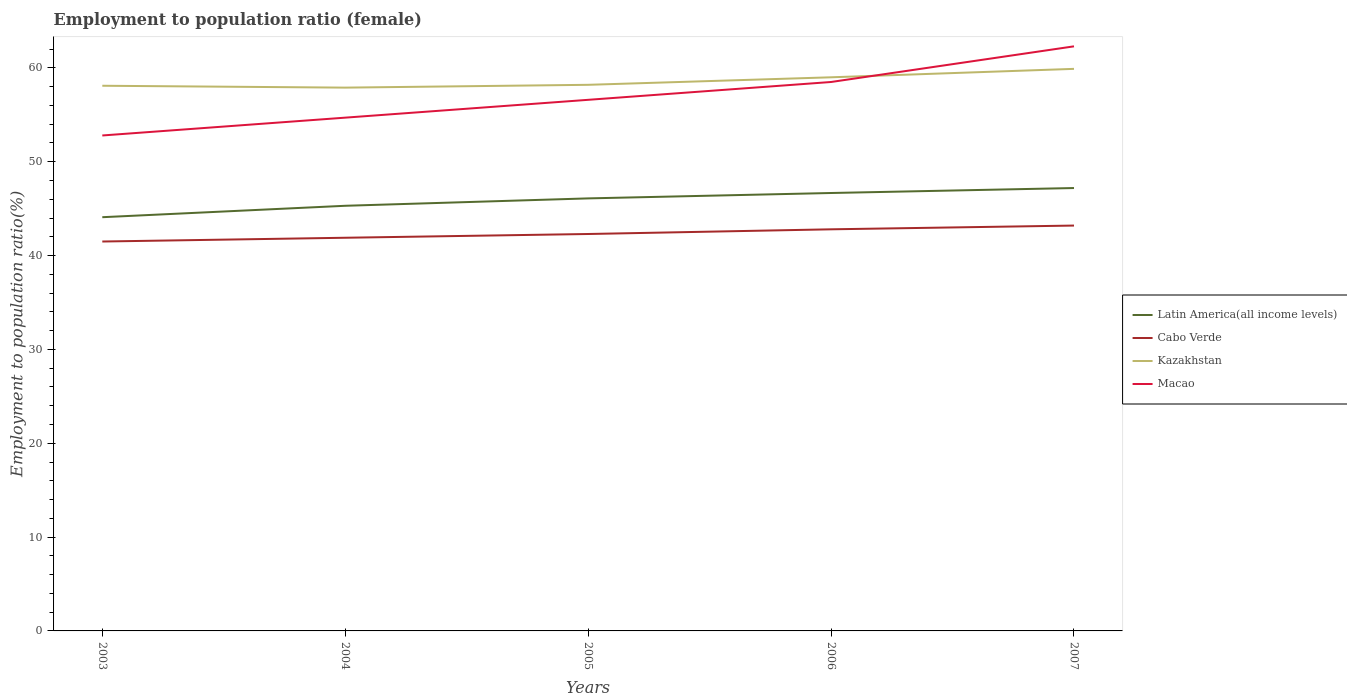How many different coloured lines are there?
Offer a very short reply. 4. Does the line corresponding to Kazakhstan intersect with the line corresponding to Cabo Verde?
Give a very brief answer. No. Across all years, what is the maximum employment to population ratio in Macao?
Give a very brief answer. 52.8. In which year was the employment to population ratio in Cabo Verde maximum?
Your answer should be compact. 2003. What is the total employment to population ratio in Cabo Verde in the graph?
Your response must be concise. -0.9. What is the difference between the highest and the second highest employment to population ratio in Latin America(all income levels)?
Your response must be concise. 3.11. What is the difference between the highest and the lowest employment to population ratio in Latin America(all income levels)?
Offer a terse response. 3. How many lines are there?
Ensure brevity in your answer.  4. Does the graph contain grids?
Your answer should be compact. No. What is the title of the graph?
Your response must be concise. Employment to population ratio (female). What is the label or title of the Y-axis?
Your answer should be very brief. Employment to population ratio(%). What is the Employment to population ratio(%) in Latin America(all income levels) in 2003?
Ensure brevity in your answer.  44.09. What is the Employment to population ratio(%) of Cabo Verde in 2003?
Give a very brief answer. 41.5. What is the Employment to population ratio(%) of Kazakhstan in 2003?
Keep it short and to the point. 58.1. What is the Employment to population ratio(%) in Macao in 2003?
Provide a succinct answer. 52.8. What is the Employment to population ratio(%) of Latin America(all income levels) in 2004?
Your response must be concise. 45.31. What is the Employment to population ratio(%) in Cabo Verde in 2004?
Provide a short and direct response. 41.9. What is the Employment to population ratio(%) of Kazakhstan in 2004?
Offer a terse response. 57.9. What is the Employment to population ratio(%) of Macao in 2004?
Give a very brief answer. 54.7. What is the Employment to population ratio(%) in Latin America(all income levels) in 2005?
Your response must be concise. 46.09. What is the Employment to population ratio(%) of Cabo Verde in 2005?
Offer a very short reply. 42.3. What is the Employment to population ratio(%) in Kazakhstan in 2005?
Your answer should be very brief. 58.2. What is the Employment to population ratio(%) in Macao in 2005?
Your answer should be very brief. 56.6. What is the Employment to population ratio(%) in Latin America(all income levels) in 2006?
Your response must be concise. 46.67. What is the Employment to population ratio(%) of Cabo Verde in 2006?
Your answer should be very brief. 42.8. What is the Employment to population ratio(%) in Kazakhstan in 2006?
Offer a very short reply. 59. What is the Employment to population ratio(%) in Macao in 2006?
Offer a terse response. 58.5. What is the Employment to population ratio(%) of Latin America(all income levels) in 2007?
Your answer should be compact. 47.2. What is the Employment to population ratio(%) of Cabo Verde in 2007?
Offer a very short reply. 43.2. What is the Employment to population ratio(%) of Kazakhstan in 2007?
Offer a very short reply. 59.9. What is the Employment to population ratio(%) of Macao in 2007?
Keep it short and to the point. 62.3. Across all years, what is the maximum Employment to population ratio(%) in Latin America(all income levels)?
Provide a short and direct response. 47.2. Across all years, what is the maximum Employment to population ratio(%) of Cabo Verde?
Offer a very short reply. 43.2. Across all years, what is the maximum Employment to population ratio(%) in Kazakhstan?
Keep it short and to the point. 59.9. Across all years, what is the maximum Employment to population ratio(%) in Macao?
Offer a very short reply. 62.3. Across all years, what is the minimum Employment to population ratio(%) in Latin America(all income levels)?
Your answer should be compact. 44.09. Across all years, what is the minimum Employment to population ratio(%) of Cabo Verde?
Your answer should be compact. 41.5. Across all years, what is the minimum Employment to population ratio(%) in Kazakhstan?
Make the answer very short. 57.9. Across all years, what is the minimum Employment to population ratio(%) in Macao?
Your answer should be compact. 52.8. What is the total Employment to population ratio(%) in Latin America(all income levels) in the graph?
Ensure brevity in your answer.  229.36. What is the total Employment to population ratio(%) in Cabo Verde in the graph?
Your response must be concise. 211.7. What is the total Employment to population ratio(%) in Kazakhstan in the graph?
Offer a terse response. 293.1. What is the total Employment to population ratio(%) in Macao in the graph?
Make the answer very short. 284.9. What is the difference between the Employment to population ratio(%) in Latin America(all income levels) in 2003 and that in 2004?
Your answer should be compact. -1.22. What is the difference between the Employment to population ratio(%) of Latin America(all income levels) in 2003 and that in 2005?
Provide a short and direct response. -2. What is the difference between the Employment to population ratio(%) in Cabo Verde in 2003 and that in 2005?
Offer a very short reply. -0.8. What is the difference between the Employment to population ratio(%) in Kazakhstan in 2003 and that in 2005?
Make the answer very short. -0.1. What is the difference between the Employment to population ratio(%) in Latin America(all income levels) in 2003 and that in 2006?
Make the answer very short. -2.58. What is the difference between the Employment to population ratio(%) of Latin America(all income levels) in 2003 and that in 2007?
Provide a succinct answer. -3.11. What is the difference between the Employment to population ratio(%) in Macao in 2003 and that in 2007?
Provide a short and direct response. -9.5. What is the difference between the Employment to population ratio(%) of Latin America(all income levels) in 2004 and that in 2005?
Make the answer very short. -0.79. What is the difference between the Employment to population ratio(%) in Cabo Verde in 2004 and that in 2005?
Make the answer very short. -0.4. What is the difference between the Employment to population ratio(%) in Kazakhstan in 2004 and that in 2005?
Make the answer very short. -0.3. What is the difference between the Employment to population ratio(%) in Macao in 2004 and that in 2005?
Keep it short and to the point. -1.9. What is the difference between the Employment to population ratio(%) in Latin America(all income levels) in 2004 and that in 2006?
Provide a short and direct response. -1.36. What is the difference between the Employment to population ratio(%) of Kazakhstan in 2004 and that in 2006?
Offer a very short reply. -1.1. What is the difference between the Employment to population ratio(%) of Macao in 2004 and that in 2006?
Provide a short and direct response. -3.8. What is the difference between the Employment to population ratio(%) in Latin America(all income levels) in 2004 and that in 2007?
Your answer should be compact. -1.89. What is the difference between the Employment to population ratio(%) of Macao in 2004 and that in 2007?
Your answer should be very brief. -7.6. What is the difference between the Employment to population ratio(%) of Latin America(all income levels) in 2005 and that in 2006?
Give a very brief answer. -0.58. What is the difference between the Employment to population ratio(%) in Cabo Verde in 2005 and that in 2006?
Offer a very short reply. -0.5. What is the difference between the Employment to population ratio(%) in Kazakhstan in 2005 and that in 2006?
Give a very brief answer. -0.8. What is the difference between the Employment to population ratio(%) in Latin America(all income levels) in 2005 and that in 2007?
Make the answer very short. -1.1. What is the difference between the Employment to population ratio(%) of Macao in 2005 and that in 2007?
Ensure brevity in your answer.  -5.7. What is the difference between the Employment to population ratio(%) of Latin America(all income levels) in 2006 and that in 2007?
Your response must be concise. -0.53. What is the difference between the Employment to population ratio(%) in Cabo Verde in 2006 and that in 2007?
Keep it short and to the point. -0.4. What is the difference between the Employment to population ratio(%) of Macao in 2006 and that in 2007?
Give a very brief answer. -3.8. What is the difference between the Employment to population ratio(%) of Latin America(all income levels) in 2003 and the Employment to population ratio(%) of Cabo Verde in 2004?
Make the answer very short. 2.19. What is the difference between the Employment to population ratio(%) of Latin America(all income levels) in 2003 and the Employment to population ratio(%) of Kazakhstan in 2004?
Keep it short and to the point. -13.81. What is the difference between the Employment to population ratio(%) of Latin America(all income levels) in 2003 and the Employment to population ratio(%) of Macao in 2004?
Make the answer very short. -10.61. What is the difference between the Employment to population ratio(%) of Cabo Verde in 2003 and the Employment to population ratio(%) of Kazakhstan in 2004?
Give a very brief answer. -16.4. What is the difference between the Employment to population ratio(%) of Cabo Verde in 2003 and the Employment to population ratio(%) of Macao in 2004?
Keep it short and to the point. -13.2. What is the difference between the Employment to population ratio(%) in Latin America(all income levels) in 2003 and the Employment to population ratio(%) in Cabo Verde in 2005?
Ensure brevity in your answer.  1.79. What is the difference between the Employment to population ratio(%) in Latin America(all income levels) in 2003 and the Employment to population ratio(%) in Kazakhstan in 2005?
Ensure brevity in your answer.  -14.11. What is the difference between the Employment to population ratio(%) in Latin America(all income levels) in 2003 and the Employment to population ratio(%) in Macao in 2005?
Your response must be concise. -12.51. What is the difference between the Employment to population ratio(%) of Cabo Verde in 2003 and the Employment to population ratio(%) of Kazakhstan in 2005?
Ensure brevity in your answer.  -16.7. What is the difference between the Employment to population ratio(%) in Cabo Verde in 2003 and the Employment to population ratio(%) in Macao in 2005?
Offer a very short reply. -15.1. What is the difference between the Employment to population ratio(%) in Kazakhstan in 2003 and the Employment to population ratio(%) in Macao in 2005?
Keep it short and to the point. 1.5. What is the difference between the Employment to population ratio(%) in Latin America(all income levels) in 2003 and the Employment to population ratio(%) in Cabo Verde in 2006?
Give a very brief answer. 1.29. What is the difference between the Employment to population ratio(%) in Latin America(all income levels) in 2003 and the Employment to population ratio(%) in Kazakhstan in 2006?
Offer a terse response. -14.91. What is the difference between the Employment to population ratio(%) in Latin America(all income levels) in 2003 and the Employment to population ratio(%) in Macao in 2006?
Your answer should be compact. -14.41. What is the difference between the Employment to population ratio(%) of Cabo Verde in 2003 and the Employment to population ratio(%) of Kazakhstan in 2006?
Give a very brief answer. -17.5. What is the difference between the Employment to population ratio(%) of Kazakhstan in 2003 and the Employment to population ratio(%) of Macao in 2006?
Your response must be concise. -0.4. What is the difference between the Employment to population ratio(%) of Latin America(all income levels) in 2003 and the Employment to population ratio(%) of Cabo Verde in 2007?
Provide a succinct answer. 0.89. What is the difference between the Employment to population ratio(%) of Latin America(all income levels) in 2003 and the Employment to population ratio(%) of Kazakhstan in 2007?
Offer a very short reply. -15.81. What is the difference between the Employment to population ratio(%) in Latin America(all income levels) in 2003 and the Employment to population ratio(%) in Macao in 2007?
Offer a terse response. -18.21. What is the difference between the Employment to population ratio(%) of Cabo Verde in 2003 and the Employment to population ratio(%) of Kazakhstan in 2007?
Provide a succinct answer. -18.4. What is the difference between the Employment to population ratio(%) in Cabo Verde in 2003 and the Employment to population ratio(%) in Macao in 2007?
Offer a terse response. -20.8. What is the difference between the Employment to population ratio(%) of Latin America(all income levels) in 2004 and the Employment to population ratio(%) of Cabo Verde in 2005?
Provide a short and direct response. 3.01. What is the difference between the Employment to population ratio(%) in Latin America(all income levels) in 2004 and the Employment to population ratio(%) in Kazakhstan in 2005?
Your answer should be compact. -12.89. What is the difference between the Employment to population ratio(%) in Latin America(all income levels) in 2004 and the Employment to population ratio(%) in Macao in 2005?
Your response must be concise. -11.29. What is the difference between the Employment to population ratio(%) of Cabo Verde in 2004 and the Employment to population ratio(%) of Kazakhstan in 2005?
Give a very brief answer. -16.3. What is the difference between the Employment to population ratio(%) in Cabo Verde in 2004 and the Employment to population ratio(%) in Macao in 2005?
Keep it short and to the point. -14.7. What is the difference between the Employment to population ratio(%) in Kazakhstan in 2004 and the Employment to population ratio(%) in Macao in 2005?
Provide a short and direct response. 1.3. What is the difference between the Employment to population ratio(%) in Latin America(all income levels) in 2004 and the Employment to population ratio(%) in Cabo Verde in 2006?
Your answer should be compact. 2.51. What is the difference between the Employment to population ratio(%) of Latin America(all income levels) in 2004 and the Employment to population ratio(%) of Kazakhstan in 2006?
Give a very brief answer. -13.69. What is the difference between the Employment to population ratio(%) of Latin America(all income levels) in 2004 and the Employment to population ratio(%) of Macao in 2006?
Provide a short and direct response. -13.19. What is the difference between the Employment to population ratio(%) in Cabo Verde in 2004 and the Employment to population ratio(%) in Kazakhstan in 2006?
Your answer should be very brief. -17.1. What is the difference between the Employment to population ratio(%) in Cabo Verde in 2004 and the Employment to population ratio(%) in Macao in 2006?
Make the answer very short. -16.6. What is the difference between the Employment to population ratio(%) of Kazakhstan in 2004 and the Employment to population ratio(%) of Macao in 2006?
Your answer should be compact. -0.6. What is the difference between the Employment to population ratio(%) in Latin America(all income levels) in 2004 and the Employment to population ratio(%) in Cabo Verde in 2007?
Give a very brief answer. 2.11. What is the difference between the Employment to population ratio(%) in Latin America(all income levels) in 2004 and the Employment to population ratio(%) in Kazakhstan in 2007?
Your answer should be very brief. -14.59. What is the difference between the Employment to population ratio(%) of Latin America(all income levels) in 2004 and the Employment to population ratio(%) of Macao in 2007?
Make the answer very short. -16.99. What is the difference between the Employment to population ratio(%) of Cabo Verde in 2004 and the Employment to population ratio(%) of Macao in 2007?
Your response must be concise. -20.4. What is the difference between the Employment to population ratio(%) of Kazakhstan in 2004 and the Employment to population ratio(%) of Macao in 2007?
Provide a short and direct response. -4.4. What is the difference between the Employment to population ratio(%) of Latin America(all income levels) in 2005 and the Employment to population ratio(%) of Cabo Verde in 2006?
Give a very brief answer. 3.29. What is the difference between the Employment to population ratio(%) in Latin America(all income levels) in 2005 and the Employment to population ratio(%) in Kazakhstan in 2006?
Your answer should be very brief. -12.91. What is the difference between the Employment to population ratio(%) in Latin America(all income levels) in 2005 and the Employment to population ratio(%) in Macao in 2006?
Offer a very short reply. -12.41. What is the difference between the Employment to population ratio(%) in Cabo Verde in 2005 and the Employment to population ratio(%) in Kazakhstan in 2006?
Your response must be concise. -16.7. What is the difference between the Employment to population ratio(%) in Cabo Verde in 2005 and the Employment to population ratio(%) in Macao in 2006?
Ensure brevity in your answer.  -16.2. What is the difference between the Employment to population ratio(%) in Latin America(all income levels) in 2005 and the Employment to population ratio(%) in Cabo Verde in 2007?
Keep it short and to the point. 2.89. What is the difference between the Employment to population ratio(%) of Latin America(all income levels) in 2005 and the Employment to population ratio(%) of Kazakhstan in 2007?
Provide a short and direct response. -13.81. What is the difference between the Employment to population ratio(%) in Latin America(all income levels) in 2005 and the Employment to population ratio(%) in Macao in 2007?
Your response must be concise. -16.21. What is the difference between the Employment to population ratio(%) of Cabo Verde in 2005 and the Employment to population ratio(%) of Kazakhstan in 2007?
Provide a short and direct response. -17.6. What is the difference between the Employment to population ratio(%) of Cabo Verde in 2005 and the Employment to population ratio(%) of Macao in 2007?
Provide a short and direct response. -20. What is the difference between the Employment to population ratio(%) of Latin America(all income levels) in 2006 and the Employment to population ratio(%) of Cabo Verde in 2007?
Give a very brief answer. 3.47. What is the difference between the Employment to population ratio(%) of Latin America(all income levels) in 2006 and the Employment to population ratio(%) of Kazakhstan in 2007?
Make the answer very short. -13.23. What is the difference between the Employment to population ratio(%) of Latin America(all income levels) in 2006 and the Employment to population ratio(%) of Macao in 2007?
Your response must be concise. -15.63. What is the difference between the Employment to population ratio(%) of Cabo Verde in 2006 and the Employment to population ratio(%) of Kazakhstan in 2007?
Provide a succinct answer. -17.1. What is the difference between the Employment to population ratio(%) in Cabo Verde in 2006 and the Employment to population ratio(%) in Macao in 2007?
Your response must be concise. -19.5. What is the difference between the Employment to population ratio(%) in Kazakhstan in 2006 and the Employment to population ratio(%) in Macao in 2007?
Offer a terse response. -3.3. What is the average Employment to population ratio(%) of Latin America(all income levels) per year?
Provide a short and direct response. 45.87. What is the average Employment to population ratio(%) in Cabo Verde per year?
Make the answer very short. 42.34. What is the average Employment to population ratio(%) in Kazakhstan per year?
Your answer should be compact. 58.62. What is the average Employment to population ratio(%) of Macao per year?
Your response must be concise. 56.98. In the year 2003, what is the difference between the Employment to population ratio(%) in Latin America(all income levels) and Employment to population ratio(%) in Cabo Verde?
Offer a very short reply. 2.59. In the year 2003, what is the difference between the Employment to population ratio(%) of Latin America(all income levels) and Employment to population ratio(%) of Kazakhstan?
Give a very brief answer. -14.01. In the year 2003, what is the difference between the Employment to population ratio(%) of Latin America(all income levels) and Employment to population ratio(%) of Macao?
Ensure brevity in your answer.  -8.71. In the year 2003, what is the difference between the Employment to population ratio(%) of Cabo Verde and Employment to population ratio(%) of Kazakhstan?
Make the answer very short. -16.6. In the year 2004, what is the difference between the Employment to population ratio(%) in Latin America(all income levels) and Employment to population ratio(%) in Cabo Verde?
Your answer should be compact. 3.41. In the year 2004, what is the difference between the Employment to population ratio(%) in Latin America(all income levels) and Employment to population ratio(%) in Kazakhstan?
Ensure brevity in your answer.  -12.59. In the year 2004, what is the difference between the Employment to population ratio(%) in Latin America(all income levels) and Employment to population ratio(%) in Macao?
Make the answer very short. -9.39. In the year 2004, what is the difference between the Employment to population ratio(%) of Cabo Verde and Employment to population ratio(%) of Kazakhstan?
Provide a succinct answer. -16. In the year 2004, what is the difference between the Employment to population ratio(%) of Cabo Verde and Employment to population ratio(%) of Macao?
Your answer should be very brief. -12.8. In the year 2005, what is the difference between the Employment to population ratio(%) in Latin America(all income levels) and Employment to population ratio(%) in Cabo Verde?
Offer a very short reply. 3.79. In the year 2005, what is the difference between the Employment to population ratio(%) in Latin America(all income levels) and Employment to population ratio(%) in Kazakhstan?
Provide a succinct answer. -12.11. In the year 2005, what is the difference between the Employment to population ratio(%) of Latin America(all income levels) and Employment to population ratio(%) of Macao?
Offer a very short reply. -10.51. In the year 2005, what is the difference between the Employment to population ratio(%) in Cabo Verde and Employment to population ratio(%) in Kazakhstan?
Ensure brevity in your answer.  -15.9. In the year 2005, what is the difference between the Employment to population ratio(%) of Cabo Verde and Employment to population ratio(%) of Macao?
Your answer should be compact. -14.3. In the year 2006, what is the difference between the Employment to population ratio(%) of Latin America(all income levels) and Employment to population ratio(%) of Cabo Verde?
Your response must be concise. 3.87. In the year 2006, what is the difference between the Employment to population ratio(%) in Latin America(all income levels) and Employment to population ratio(%) in Kazakhstan?
Your response must be concise. -12.33. In the year 2006, what is the difference between the Employment to population ratio(%) in Latin America(all income levels) and Employment to population ratio(%) in Macao?
Ensure brevity in your answer.  -11.83. In the year 2006, what is the difference between the Employment to population ratio(%) in Cabo Verde and Employment to population ratio(%) in Kazakhstan?
Keep it short and to the point. -16.2. In the year 2006, what is the difference between the Employment to population ratio(%) in Cabo Verde and Employment to population ratio(%) in Macao?
Ensure brevity in your answer.  -15.7. In the year 2006, what is the difference between the Employment to population ratio(%) in Kazakhstan and Employment to population ratio(%) in Macao?
Give a very brief answer. 0.5. In the year 2007, what is the difference between the Employment to population ratio(%) in Latin America(all income levels) and Employment to population ratio(%) in Cabo Verde?
Your answer should be compact. 4. In the year 2007, what is the difference between the Employment to population ratio(%) of Latin America(all income levels) and Employment to population ratio(%) of Kazakhstan?
Give a very brief answer. -12.7. In the year 2007, what is the difference between the Employment to population ratio(%) in Latin America(all income levels) and Employment to population ratio(%) in Macao?
Provide a succinct answer. -15.1. In the year 2007, what is the difference between the Employment to population ratio(%) in Cabo Verde and Employment to population ratio(%) in Kazakhstan?
Your answer should be very brief. -16.7. In the year 2007, what is the difference between the Employment to population ratio(%) of Cabo Verde and Employment to population ratio(%) of Macao?
Provide a succinct answer. -19.1. What is the ratio of the Employment to population ratio(%) of Latin America(all income levels) in 2003 to that in 2004?
Your answer should be very brief. 0.97. What is the ratio of the Employment to population ratio(%) of Kazakhstan in 2003 to that in 2004?
Your answer should be very brief. 1. What is the ratio of the Employment to population ratio(%) in Macao in 2003 to that in 2004?
Provide a short and direct response. 0.97. What is the ratio of the Employment to population ratio(%) in Latin America(all income levels) in 2003 to that in 2005?
Ensure brevity in your answer.  0.96. What is the ratio of the Employment to population ratio(%) of Cabo Verde in 2003 to that in 2005?
Ensure brevity in your answer.  0.98. What is the ratio of the Employment to population ratio(%) in Macao in 2003 to that in 2005?
Ensure brevity in your answer.  0.93. What is the ratio of the Employment to population ratio(%) of Latin America(all income levels) in 2003 to that in 2006?
Your answer should be compact. 0.94. What is the ratio of the Employment to population ratio(%) of Cabo Verde in 2003 to that in 2006?
Keep it short and to the point. 0.97. What is the ratio of the Employment to population ratio(%) in Kazakhstan in 2003 to that in 2006?
Keep it short and to the point. 0.98. What is the ratio of the Employment to population ratio(%) in Macao in 2003 to that in 2006?
Provide a short and direct response. 0.9. What is the ratio of the Employment to population ratio(%) of Latin America(all income levels) in 2003 to that in 2007?
Your answer should be compact. 0.93. What is the ratio of the Employment to population ratio(%) in Cabo Verde in 2003 to that in 2007?
Give a very brief answer. 0.96. What is the ratio of the Employment to population ratio(%) of Kazakhstan in 2003 to that in 2007?
Your answer should be very brief. 0.97. What is the ratio of the Employment to population ratio(%) of Macao in 2003 to that in 2007?
Offer a very short reply. 0.85. What is the ratio of the Employment to population ratio(%) of Latin America(all income levels) in 2004 to that in 2005?
Provide a short and direct response. 0.98. What is the ratio of the Employment to population ratio(%) of Kazakhstan in 2004 to that in 2005?
Offer a terse response. 0.99. What is the ratio of the Employment to population ratio(%) of Macao in 2004 to that in 2005?
Provide a short and direct response. 0.97. What is the ratio of the Employment to population ratio(%) of Latin America(all income levels) in 2004 to that in 2006?
Your answer should be compact. 0.97. What is the ratio of the Employment to population ratio(%) of Kazakhstan in 2004 to that in 2006?
Your answer should be compact. 0.98. What is the ratio of the Employment to population ratio(%) in Macao in 2004 to that in 2006?
Give a very brief answer. 0.94. What is the ratio of the Employment to population ratio(%) of Latin America(all income levels) in 2004 to that in 2007?
Your answer should be very brief. 0.96. What is the ratio of the Employment to population ratio(%) of Cabo Verde in 2004 to that in 2007?
Offer a very short reply. 0.97. What is the ratio of the Employment to population ratio(%) of Kazakhstan in 2004 to that in 2007?
Your answer should be very brief. 0.97. What is the ratio of the Employment to population ratio(%) in Macao in 2004 to that in 2007?
Keep it short and to the point. 0.88. What is the ratio of the Employment to population ratio(%) of Cabo Verde in 2005 to that in 2006?
Keep it short and to the point. 0.99. What is the ratio of the Employment to population ratio(%) of Kazakhstan in 2005 to that in 2006?
Provide a short and direct response. 0.99. What is the ratio of the Employment to population ratio(%) in Macao in 2005 to that in 2006?
Your answer should be compact. 0.97. What is the ratio of the Employment to population ratio(%) of Latin America(all income levels) in 2005 to that in 2007?
Provide a succinct answer. 0.98. What is the ratio of the Employment to population ratio(%) of Cabo Verde in 2005 to that in 2007?
Give a very brief answer. 0.98. What is the ratio of the Employment to population ratio(%) of Kazakhstan in 2005 to that in 2007?
Your answer should be compact. 0.97. What is the ratio of the Employment to population ratio(%) of Macao in 2005 to that in 2007?
Give a very brief answer. 0.91. What is the ratio of the Employment to population ratio(%) in Latin America(all income levels) in 2006 to that in 2007?
Offer a terse response. 0.99. What is the ratio of the Employment to population ratio(%) in Kazakhstan in 2006 to that in 2007?
Provide a succinct answer. 0.98. What is the ratio of the Employment to population ratio(%) in Macao in 2006 to that in 2007?
Give a very brief answer. 0.94. What is the difference between the highest and the second highest Employment to population ratio(%) of Latin America(all income levels)?
Your answer should be compact. 0.53. What is the difference between the highest and the second highest Employment to population ratio(%) of Cabo Verde?
Keep it short and to the point. 0.4. What is the difference between the highest and the second highest Employment to population ratio(%) in Macao?
Your answer should be compact. 3.8. What is the difference between the highest and the lowest Employment to population ratio(%) of Latin America(all income levels)?
Make the answer very short. 3.11. What is the difference between the highest and the lowest Employment to population ratio(%) of Cabo Verde?
Ensure brevity in your answer.  1.7. 